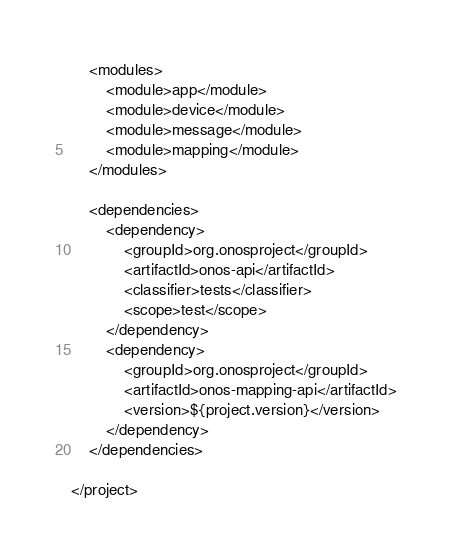Convert code to text. <code><loc_0><loc_0><loc_500><loc_500><_XML_>    <modules>
        <module>app</module>
        <module>device</module>
        <module>message</module>
        <module>mapping</module>
    </modules>

    <dependencies>
        <dependency>
            <groupId>org.onosproject</groupId>
            <artifactId>onos-api</artifactId>
            <classifier>tests</classifier>
            <scope>test</scope>
        </dependency>
        <dependency>
            <groupId>org.onosproject</groupId>
            <artifactId>onos-mapping-api</artifactId>
            <version>${project.version}</version>
        </dependency>
    </dependencies>

</project>
</code> 